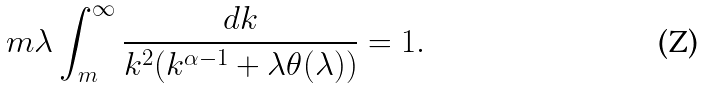Convert formula to latex. <formula><loc_0><loc_0><loc_500><loc_500>m \lambda \int _ { m } ^ { \infty } \frac { d k } { k ^ { 2 } ( k ^ { \alpha - 1 } + \lambda \theta ( \lambda ) ) } = 1 .</formula> 